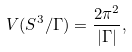Convert formula to latex. <formula><loc_0><loc_0><loc_500><loc_500>V ( S ^ { 3 } / \Gamma ) = \frac { 2 \pi ^ { 2 } } { | \Gamma | } ,</formula> 